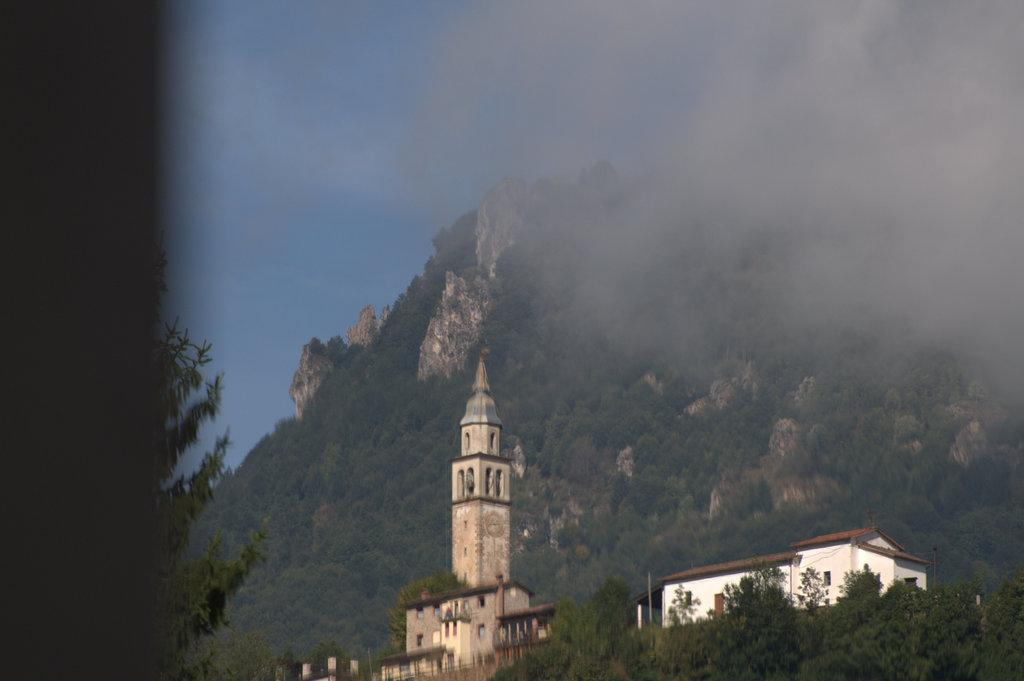What type of structures are present in the image? There are buildings in the image. What colors are the buildings? The buildings are in white and brown colors. What can be seen in the background of the image? There are trees in the background of the image. What color are the trees? The trees are in green color. What color is the sky in the image? The sky is in blue color. Where is the downtown area located in the image? There is no downtown area mentioned or visible in the image. What type of pot is being used by the trees in the image? There is no pot visible in the image; the trees are growing naturally in the background. 